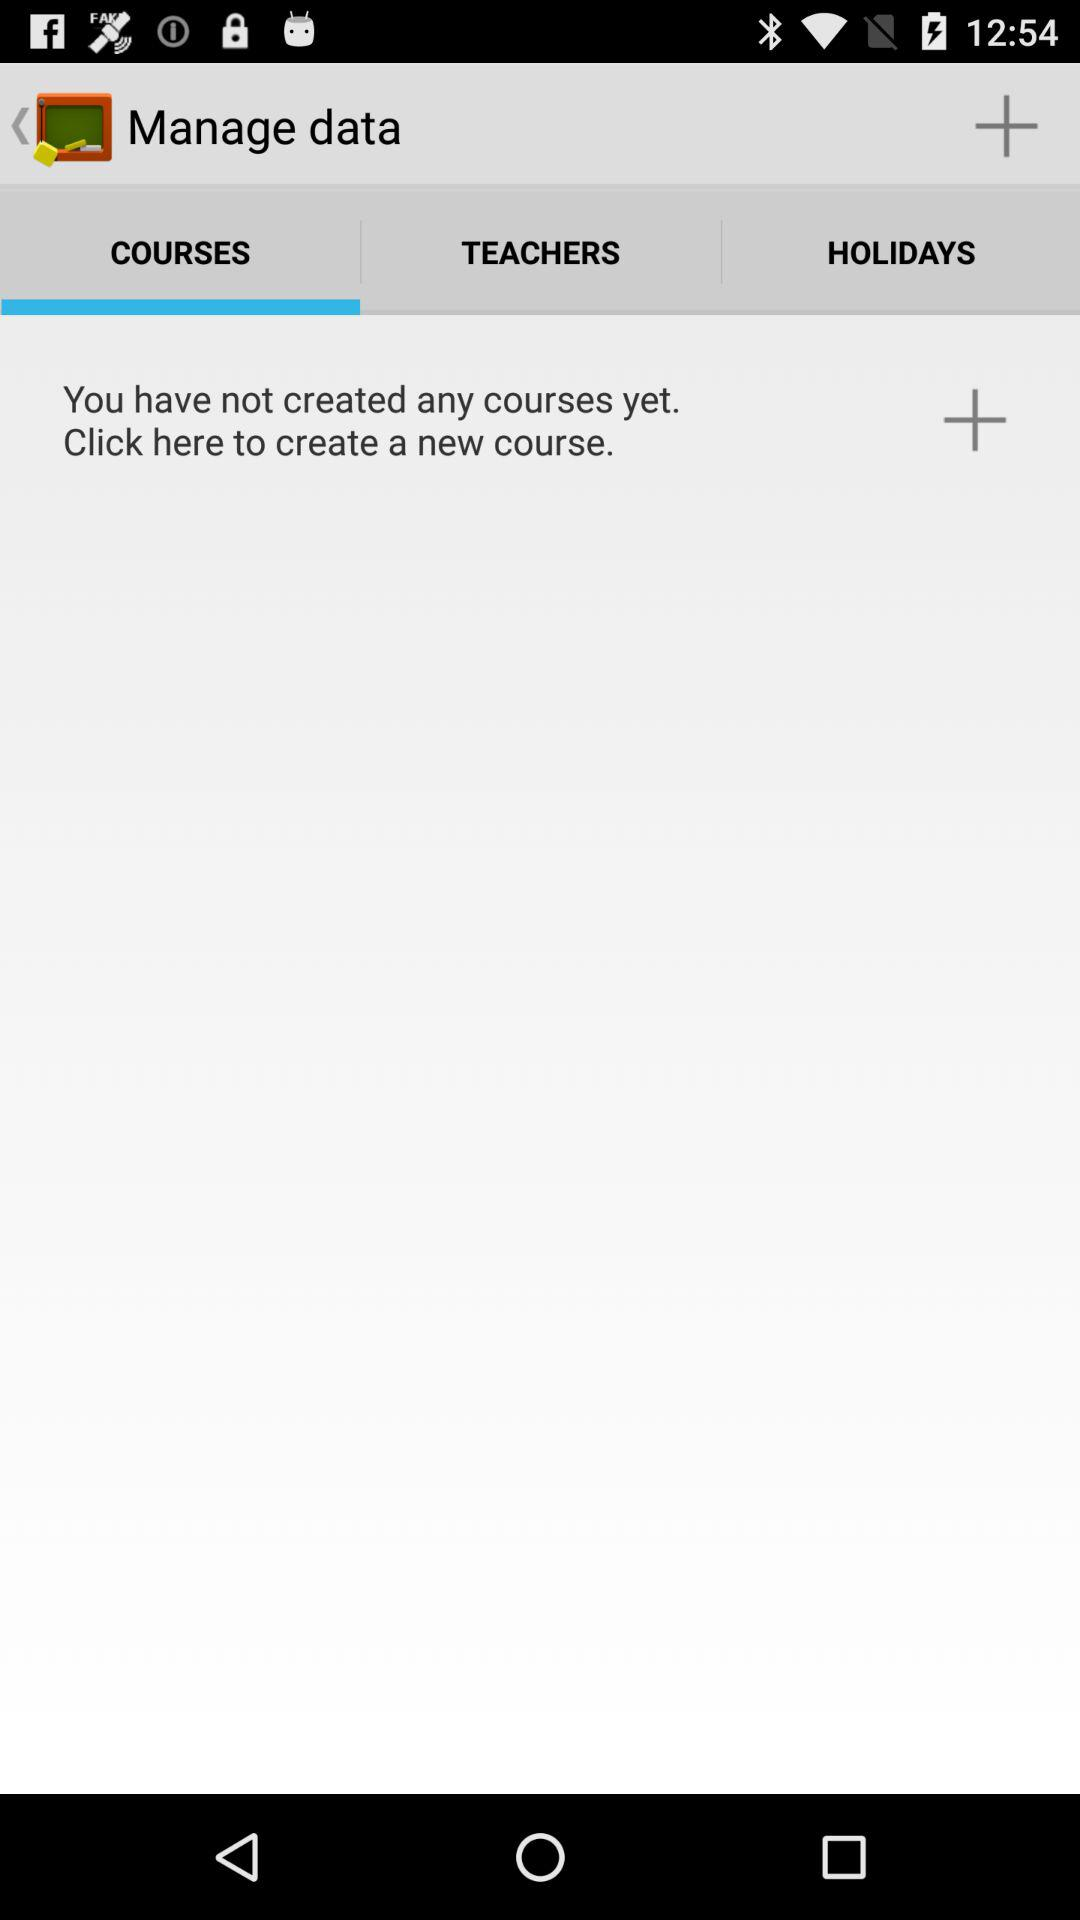Which tab is selected? The selected tab is "COURSES". 